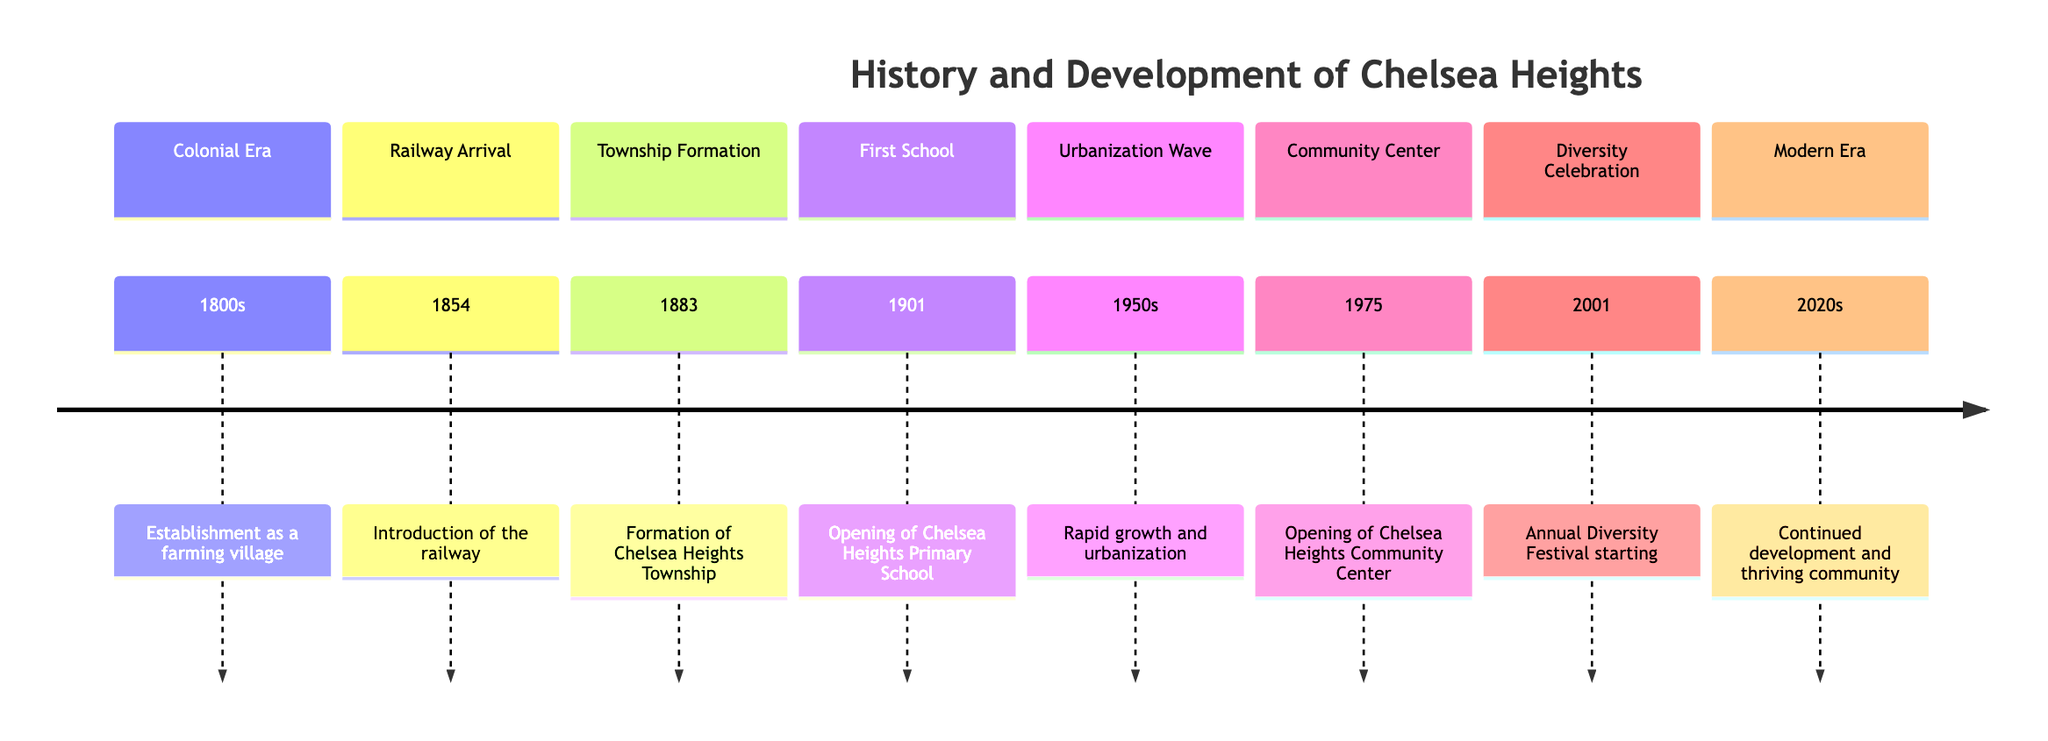What was the first significant event in Chelsea Heights' timeline? The timeline starts with the establishment of Chelsea Heights as a farming village in the 1800s, marking the first significant event.
Answer: Establishment as a farming village What year did the railway arrive in Chelsea Heights? According to the diagram, the railway was introduced in the year 1854.
Answer: 1854 How many key historical events are listed in the timeline? The diagram has a total of eight key historical events listed in different sections of the timeline.
Answer: Eight What major community development occurred in 1975? In 1975, the Chelsea Heights Community Center was opened, which is a significant development for the community.
Answer: Opening of Chelsea Heights Community Center What does the timeline indicate about the community in the 2020s? The timeline states that the 2020s are characterized by continued development and a thriving community, indicating ongoing growth and vibrancy.
Answer: Continued development and thriving community Which section refers to a celebration of diversity? The section titled "Diversity Celebration" refers to the annual festival that started in 2001, emphasizing community diversity and inclusion.
Answer: Diversity Celebration What was the main focus of urbanization in the 1950s? The 1950s were noted for rapid growth and urbanization in Chelsea Heights, which indicates a transition in the community's development.
Answer: Rapid growth and urbanization What significant educational facility opened in 1901? According to the diagram, Chelsea Heights Primary School opened in 1901, marking an important milestone for education in the community.
Answer: Opening of Chelsea Heights Primary School 